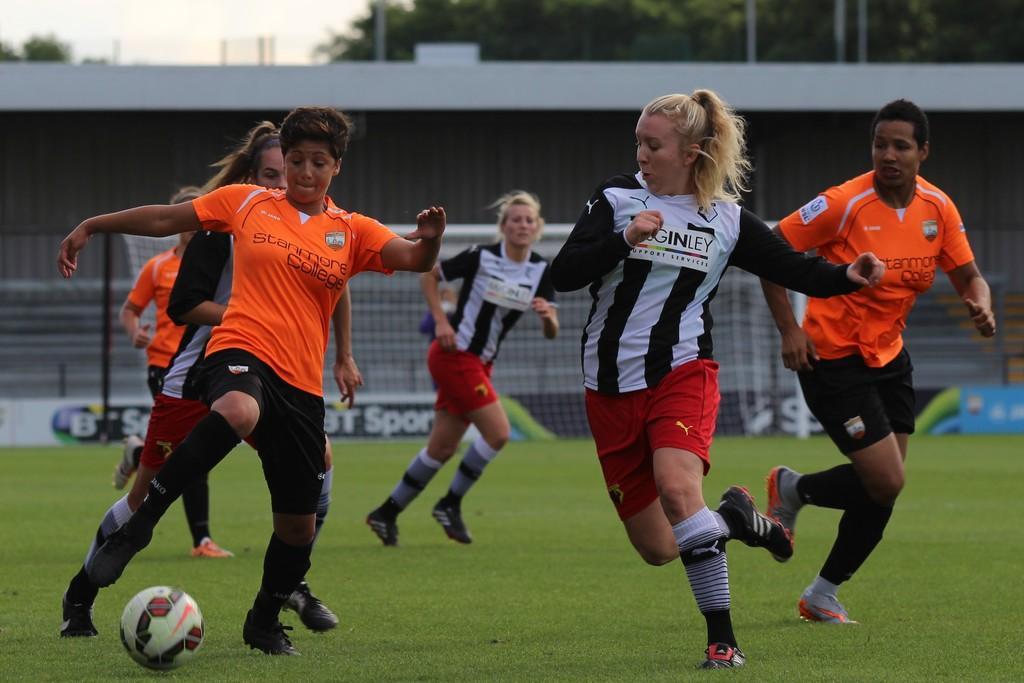Please provide a concise description of this image. This is a playing ground. Here I can see few women wearing t-shirts, shorts and playing football. On the ground, I can see the grass. In the background there is a building and also I can see a net. At the top of the image there are a few trees, poles and also I can see the sky. 